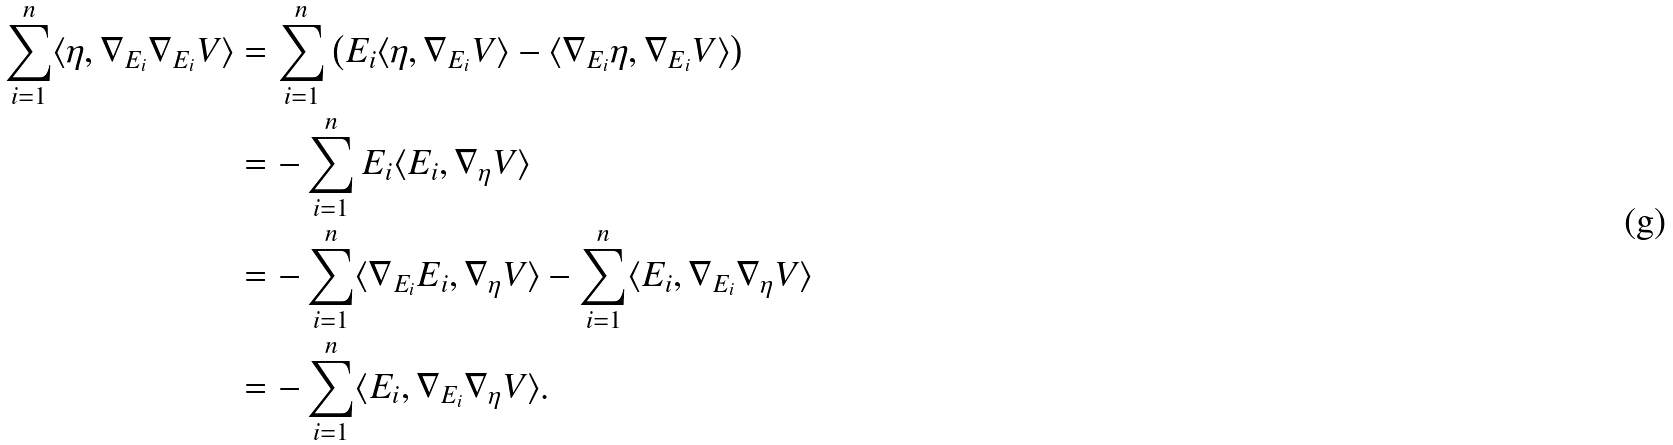<formula> <loc_0><loc_0><loc_500><loc_500>\sum _ { i = 1 } ^ { n } \langle \eta , \nabla _ { E _ { i } } \nabla _ { E _ { i } } V \rangle & = \sum _ { i = 1 } ^ { n } \left ( E _ { i } \langle \eta , \nabla _ { E _ { i } } V \rangle - \langle \nabla _ { E _ { i } } \eta , \nabla _ { E _ { i } } V \rangle \right ) \\ & = - \sum _ { i = 1 } ^ { n } E _ { i } \langle E _ { i } , \nabla _ { \eta } V \rangle \\ & = - \sum _ { i = 1 } ^ { n } \langle \nabla _ { E _ { i } } E _ { i } , \nabla _ { \eta } V \rangle - \sum _ { i = 1 } ^ { n } \langle E _ { i } , \nabla _ { E _ { i } } \nabla _ { \eta } V \rangle \\ & = - \sum _ { i = 1 } ^ { n } \langle E _ { i } , \nabla _ { E _ { i } } \nabla _ { \eta } V \rangle .</formula> 